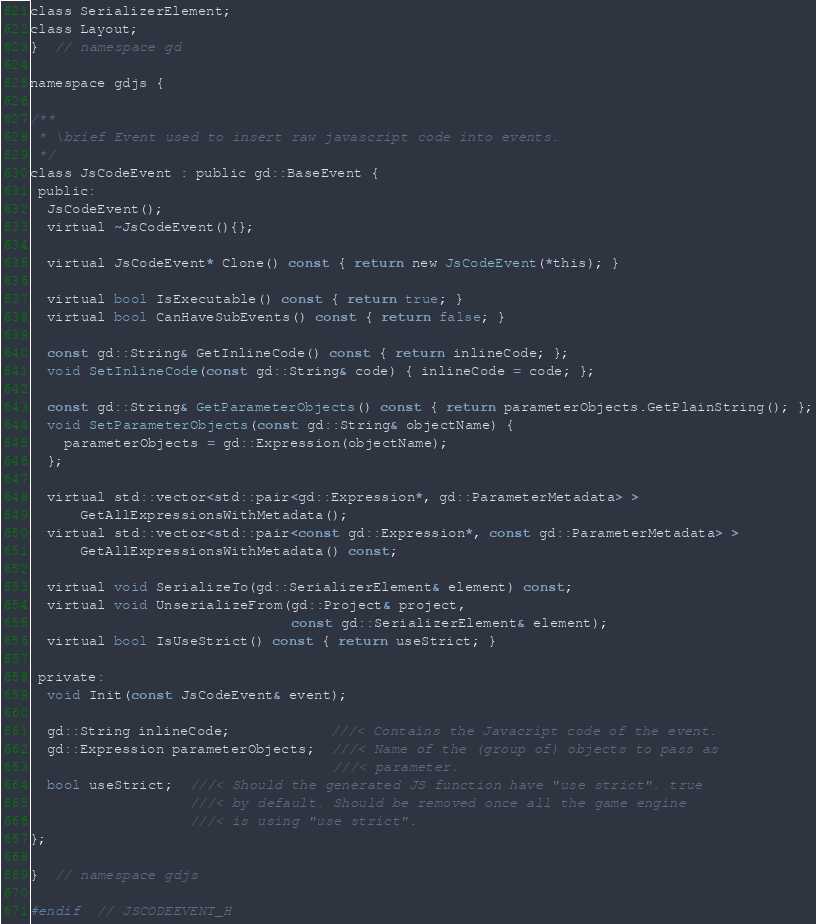<code> <loc_0><loc_0><loc_500><loc_500><_C_>class SerializerElement;
class Layout;
}  // namespace gd

namespace gdjs {

/**
 * \brief Event used to insert raw javascript code into events.
 */
class JsCodeEvent : public gd::BaseEvent {
 public:
  JsCodeEvent();
  virtual ~JsCodeEvent(){};

  virtual JsCodeEvent* Clone() const { return new JsCodeEvent(*this); }

  virtual bool IsExecutable() const { return true; }
  virtual bool CanHaveSubEvents() const { return false; }

  const gd::String& GetInlineCode() const { return inlineCode; };
  void SetInlineCode(const gd::String& code) { inlineCode = code; };

  const gd::String& GetParameterObjects() const { return parameterObjects.GetPlainString(); };
  void SetParameterObjects(const gd::String& objectName) {
    parameterObjects = gd::Expression(objectName);
  };

  virtual std::vector<std::pair<gd::Expression*, gd::ParameterMetadata> >
      GetAllExpressionsWithMetadata();
  virtual std::vector<std::pair<const gd::Expression*, const gd::ParameterMetadata> >
      GetAllExpressionsWithMetadata() const;

  virtual void SerializeTo(gd::SerializerElement& element) const;
  virtual void UnserializeFrom(gd::Project& project,
                               const gd::SerializerElement& element);
  virtual bool IsUseStrict() const { return useStrict; }

 private:
  void Init(const JsCodeEvent& event);

  gd::String inlineCode;            ///< Contains the Javacript code of the event.
  gd::Expression parameterObjects;  ///< Name of the (group of) objects to pass as
                                    ///< parameter.
  bool useStrict;  ///< Should the generated JS function have "use strict". true
                   ///< by default. Should be removed once all the game engine
                   ///< is using "use strict".
};

}  // namespace gdjs

#endif  // JSCODEEVENT_H
</code> 